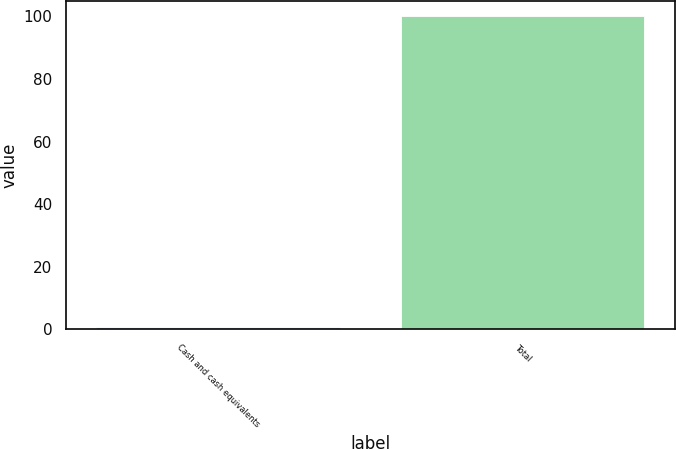<chart> <loc_0><loc_0><loc_500><loc_500><bar_chart><fcel>Cash and cash equivalents<fcel>Total<nl><fcel>0.9<fcel>100<nl></chart> 